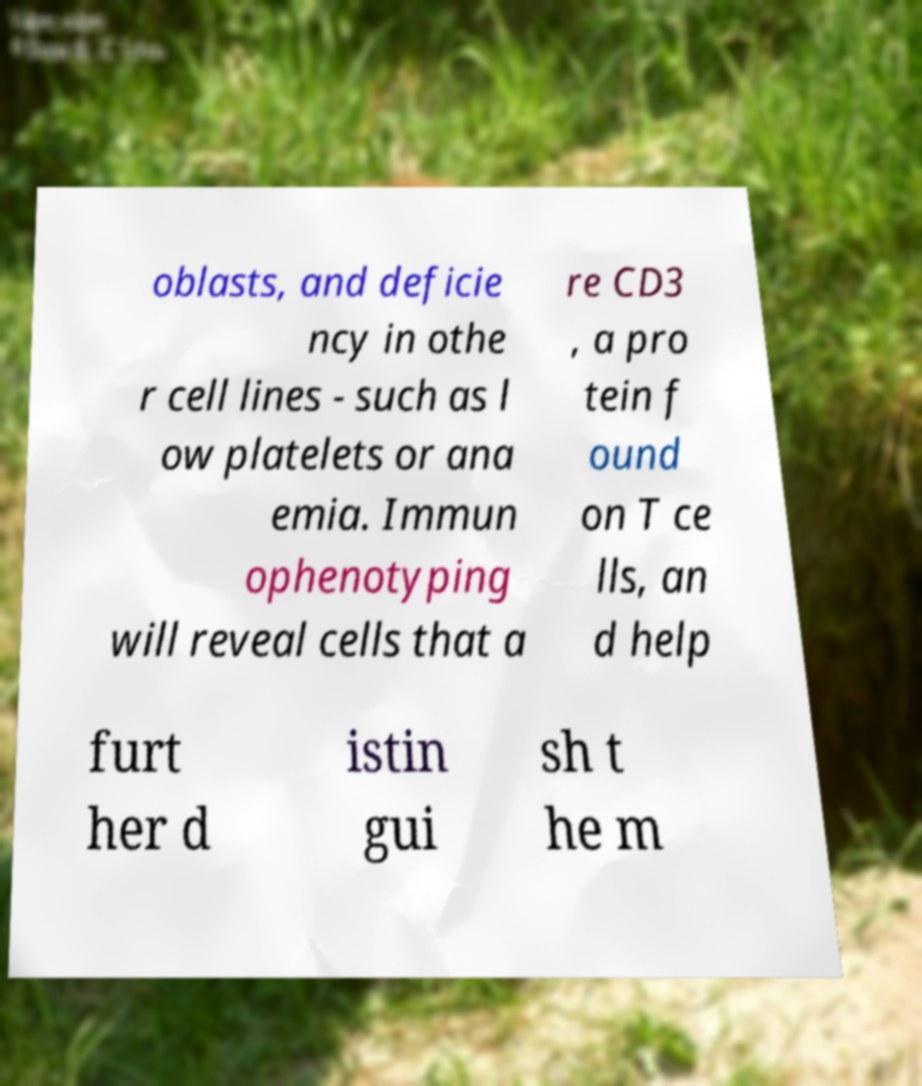Could you extract and type out the text from this image? oblasts, and deficie ncy in othe r cell lines - such as l ow platelets or ana emia. Immun ophenotyping will reveal cells that a re CD3 , a pro tein f ound on T ce lls, an d help furt her d istin gui sh t he m 